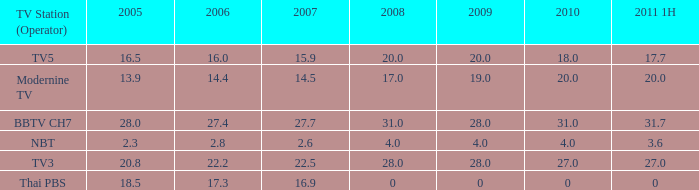How many 2011 1H values have a 2006 of 27.4 and 2007 over 27.7? 0.0. 